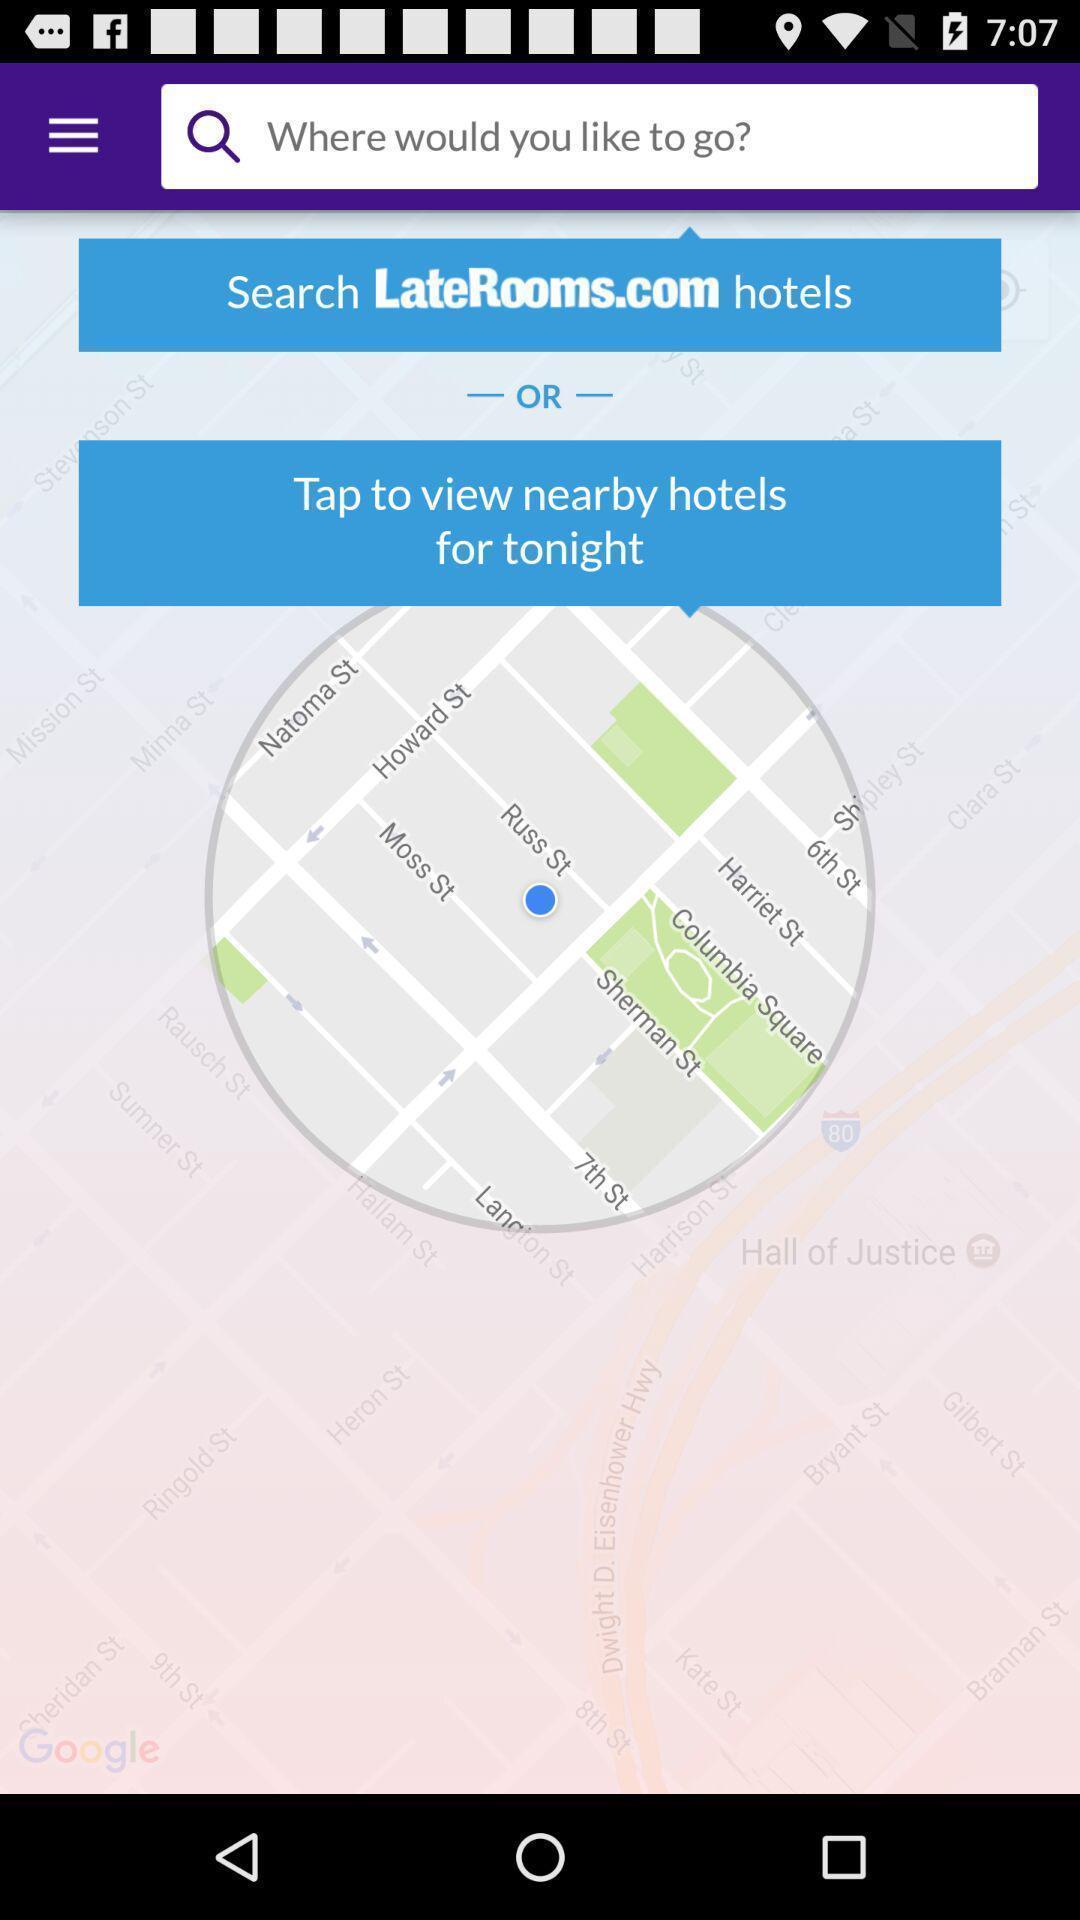What details can you identify in this image? Screen displaying the location page. 